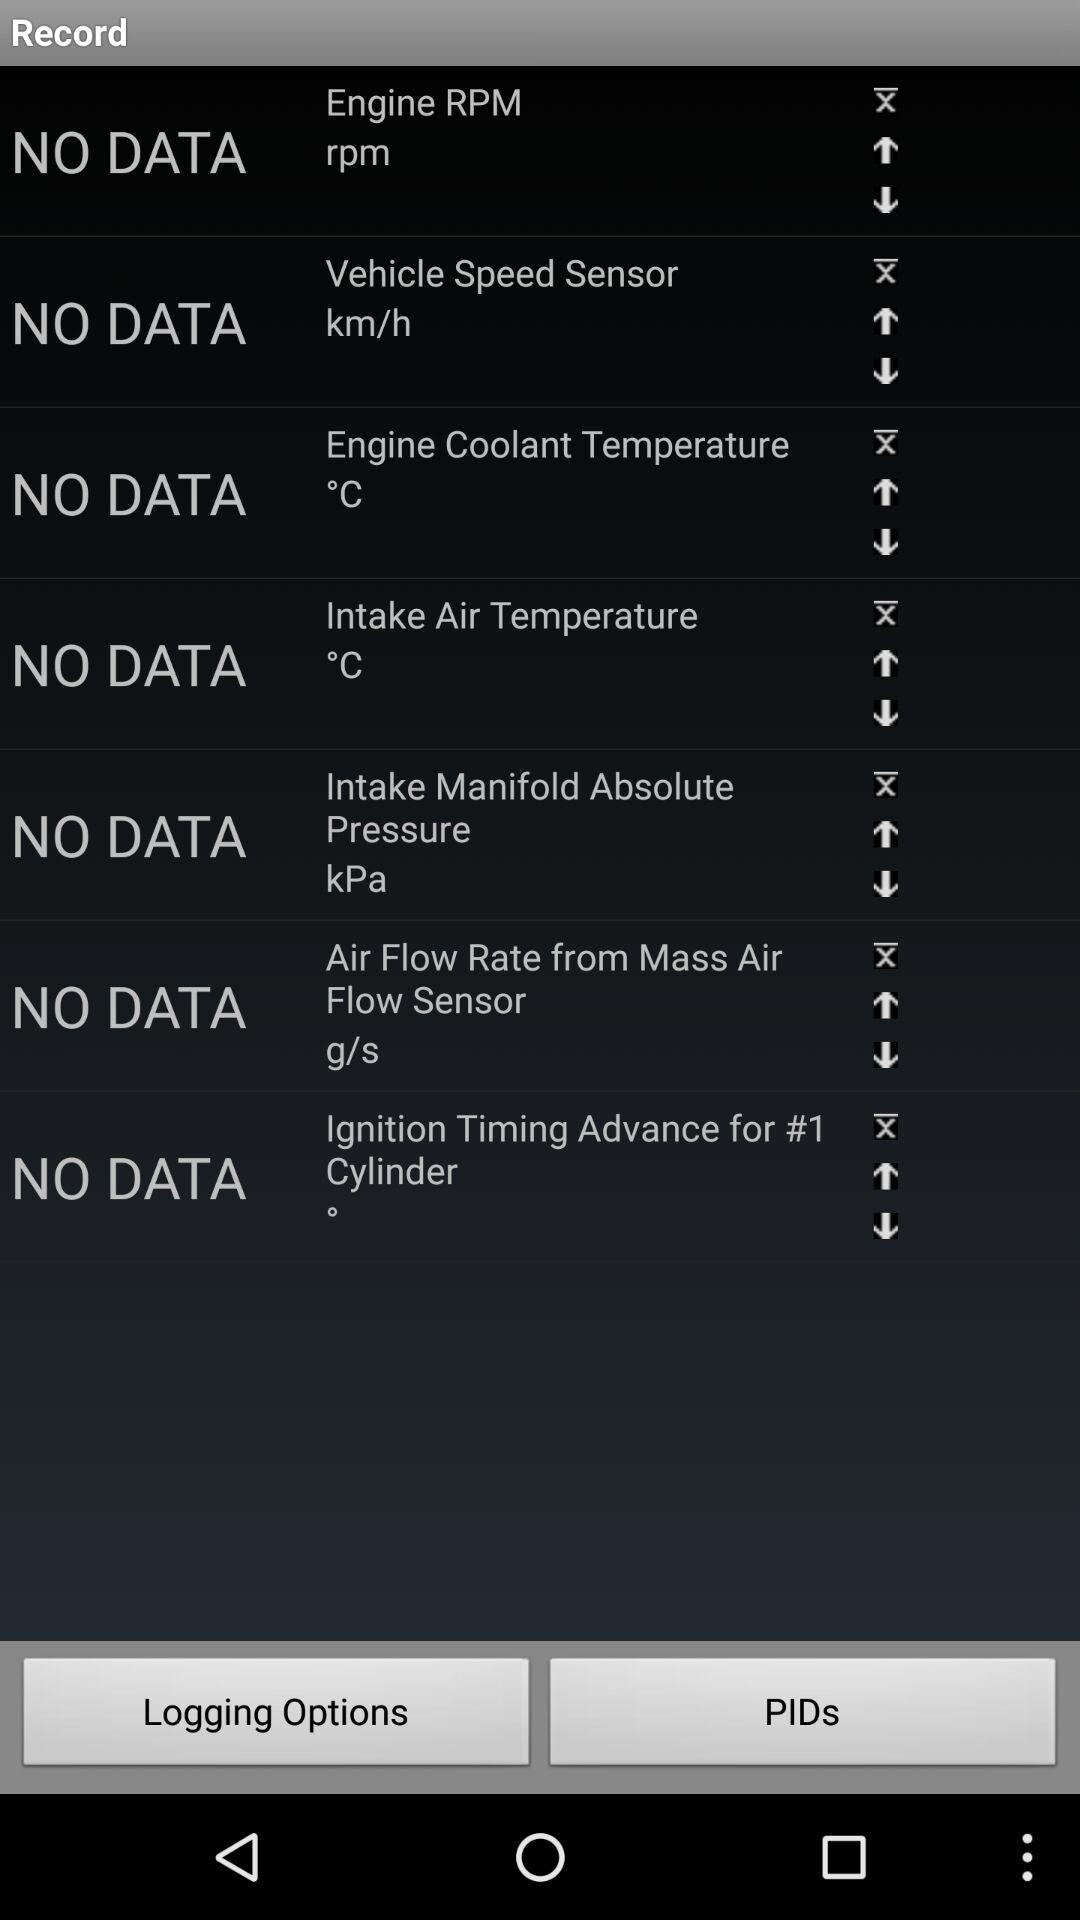What is the unit of temperature? The unit of temperature is degrees Celsius. 